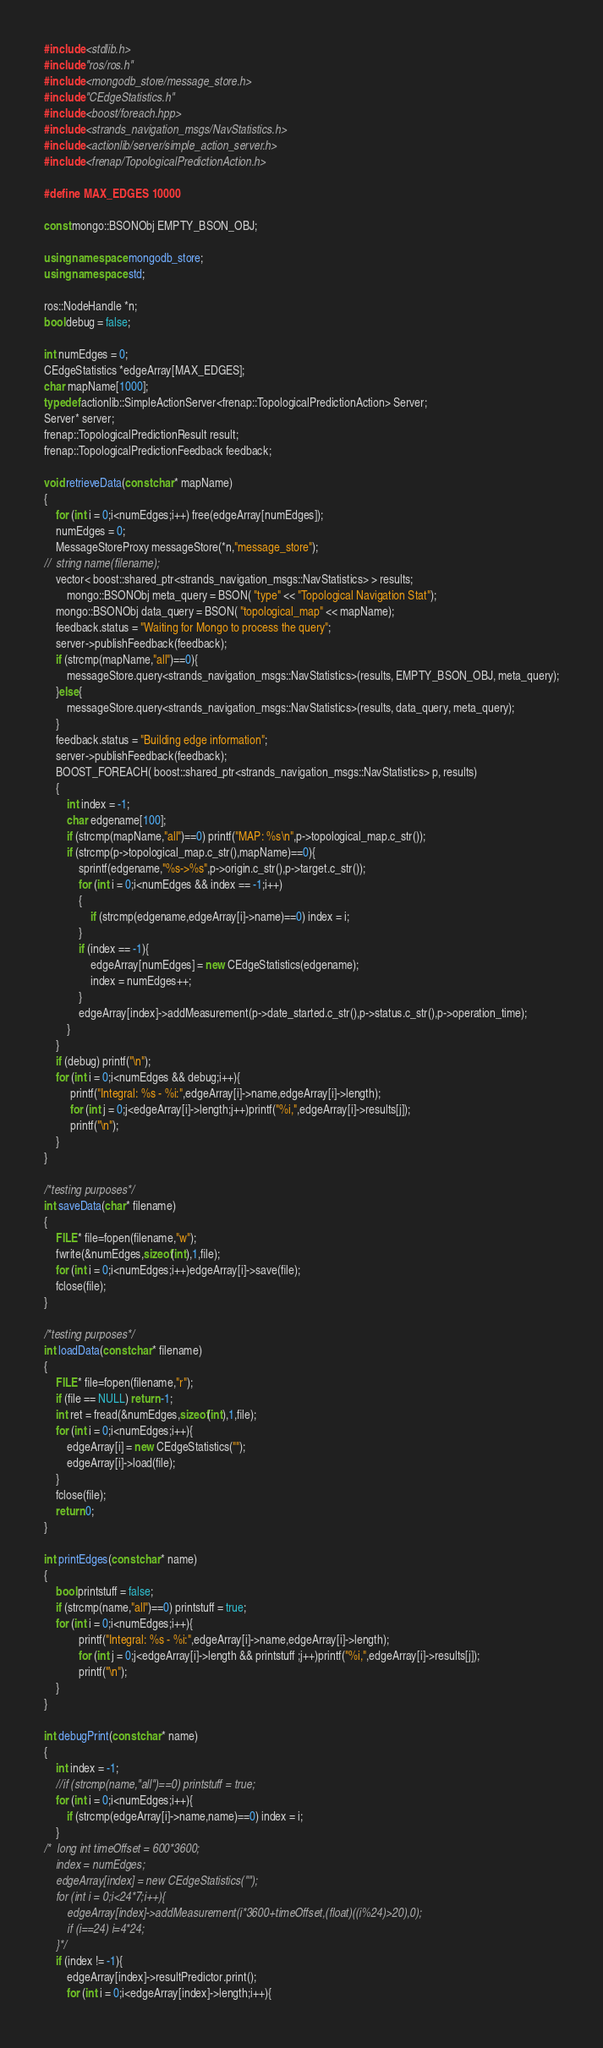<code> <loc_0><loc_0><loc_500><loc_500><_C++_>#include <stdlib.h>
#include "ros/ros.h"
#include <mongodb_store/message_store.h>
#include "CEdgeStatistics.h"
#include <boost/foreach.hpp>
#include <strands_navigation_msgs/NavStatistics.h>
#include <actionlib/server/simple_action_server.h>
#include <frenap/TopologicalPredictionAction.h>

#define MAX_EDGES 10000

const mongo::BSONObj EMPTY_BSON_OBJ;

using namespace mongodb_store;
using namespace std;

ros::NodeHandle *n;
bool debug = false;

int numEdges = 0;
CEdgeStatistics *edgeArray[MAX_EDGES];
char mapName[1000];
typedef actionlib::SimpleActionServer<frenap::TopologicalPredictionAction> Server;
Server* server;
frenap::TopologicalPredictionResult result;
frenap::TopologicalPredictionFeedback feedback;

void retrieveData(const char* mapName)
{
	for (int i = 0;i<numEdges;i++) free(edgeArray[numEdges]);
	numEdges = 0;
	MessageStoreProxy messageStore(*n,"message_store");
//	string name(filename);
	vector< boost::shared_ptr<strands_navigation_msgs::NavStatistics> > results;
        mongo::BSONObj meta_query = BSON( "type" << "Topological Navigation Stat");
	mongo::BSONObj data_query = BSON( "topological_map" << mapName);
	feedback.status = "Waiting for Mongo to process the query";
	server->publishFeedback(feedback);
	if (strcmp(mapName,"all")==0){
		messageStore.query<strands_navigation_msgs::NavStatistics>(results, EMPTY_BSON_OBJ, meta_query);
	}else{
		messageStore.query<strands_navigation_msgs::NavStatistics>(results, data_query, meta_query);
	}
	feedback.status = "Building edge information";
	server->publishFeedback(feedback);
	BOOST_FOREACH( boost::shared_ptr<strands_navigation_msgs::NavStatistics> p, results)
	{
		int index = -1;
		char edgename[100];
		if (strcmp(mapName,"all")==0) printf("MAP: %s\n",p->topological_map.c_str());
		if (strcmp(p->topological_map.c_str(),mapName)==0){
			sprintf(edgename,"%s->%s",p->origin.c_str(),p->target.c_str());
			for (int i = 0;i<numEdges && index == -1;i++)
			{	
				if (strcmp(edgename,edgeArray[i]->name)==0) index = i;
			}
			if (index == -1){
				edgeArray[numEdges] = new CEdgeStatistics(edgename);
				index = numEdges++;
			}
			edgeArray[index]->addMeasurement(p->date_started.c_str(),p->status.c_str(),p->operation_time);
		}
	}
	if (debug) printf("\n");
	for (int i = 0;i<numEdges && debug;i++){
		 printf("Integral: %s - %i:",edgeArray[i]->name,edgeArray[i]->length);
		 for (int j = 0;j<edgeArray[i]->length;j++)printf("%i,",edgeArray[i]->results[j]);
		 printf("\n");
	}
}

/*testing purposes*/
int saveData(char* filename)
{
	FILE* file=fopen(filename,"w");
	fwrite(&numEdges,sizeof(int),1,file);
	for (int i = 0;i<numEdges;i++)edgeArray[i]->save(file);
	fclose(file);
}

/*testing purposes*/
int loadData(const char* filename)
{
	FILE* file=fopen(filename,"r");
	if (file == NULL) return -1;
	int ret = fread(&numEdges,sizeof(int),1,file);
	for (int i = 0;i<numEdges;i++){
		edgeArray[i] = new CEdgeStatistics("");
		edgeArray[i]->load(file);
	}
	fclose(file);
	return 0;
}

int printEdges(const char* name)
{
	bool printstuff = false;
	if (strcmp(name,"all")==0) printstuff = true;
	for (int i = 0;i<numEdges;i++){
			printf("Integral: %s - %i:",edgeArray[i]->name,edgeArray[i]->length);
			for (int j = 0;j<edgeArray[i]->length && printstuff ;j++)printf("%i,",edgeArray[i]->results[j]);
			printf("\n");
	}
}

int debugPrint(const char* name)
{
	int index = -1;
	//if (strcmp(name,"all")==0) printstuff = true;
	for (int i = 0;i<numEdges;i++){
		if (strcmp(edgeArray[i]->name,name)==0) index = i;
	}
/*	long int timeOffset = 600*3600;
	index = numEdges;	
	edgeArray[index] = new CEdgeStatistics("");
	for (int i = 0;i<24*7;i++){
		edgeArray[index]->addMeasurement(i*3600+timeOffset,(float)((i%24)>20),0);
		if (i==24) i=4*24;
	}*/
	if (index != -1){
		edgeArray[index]->resultPredictor.print();
		for (int i = 0;i<edgeArray[index]->length;i++){</code> 